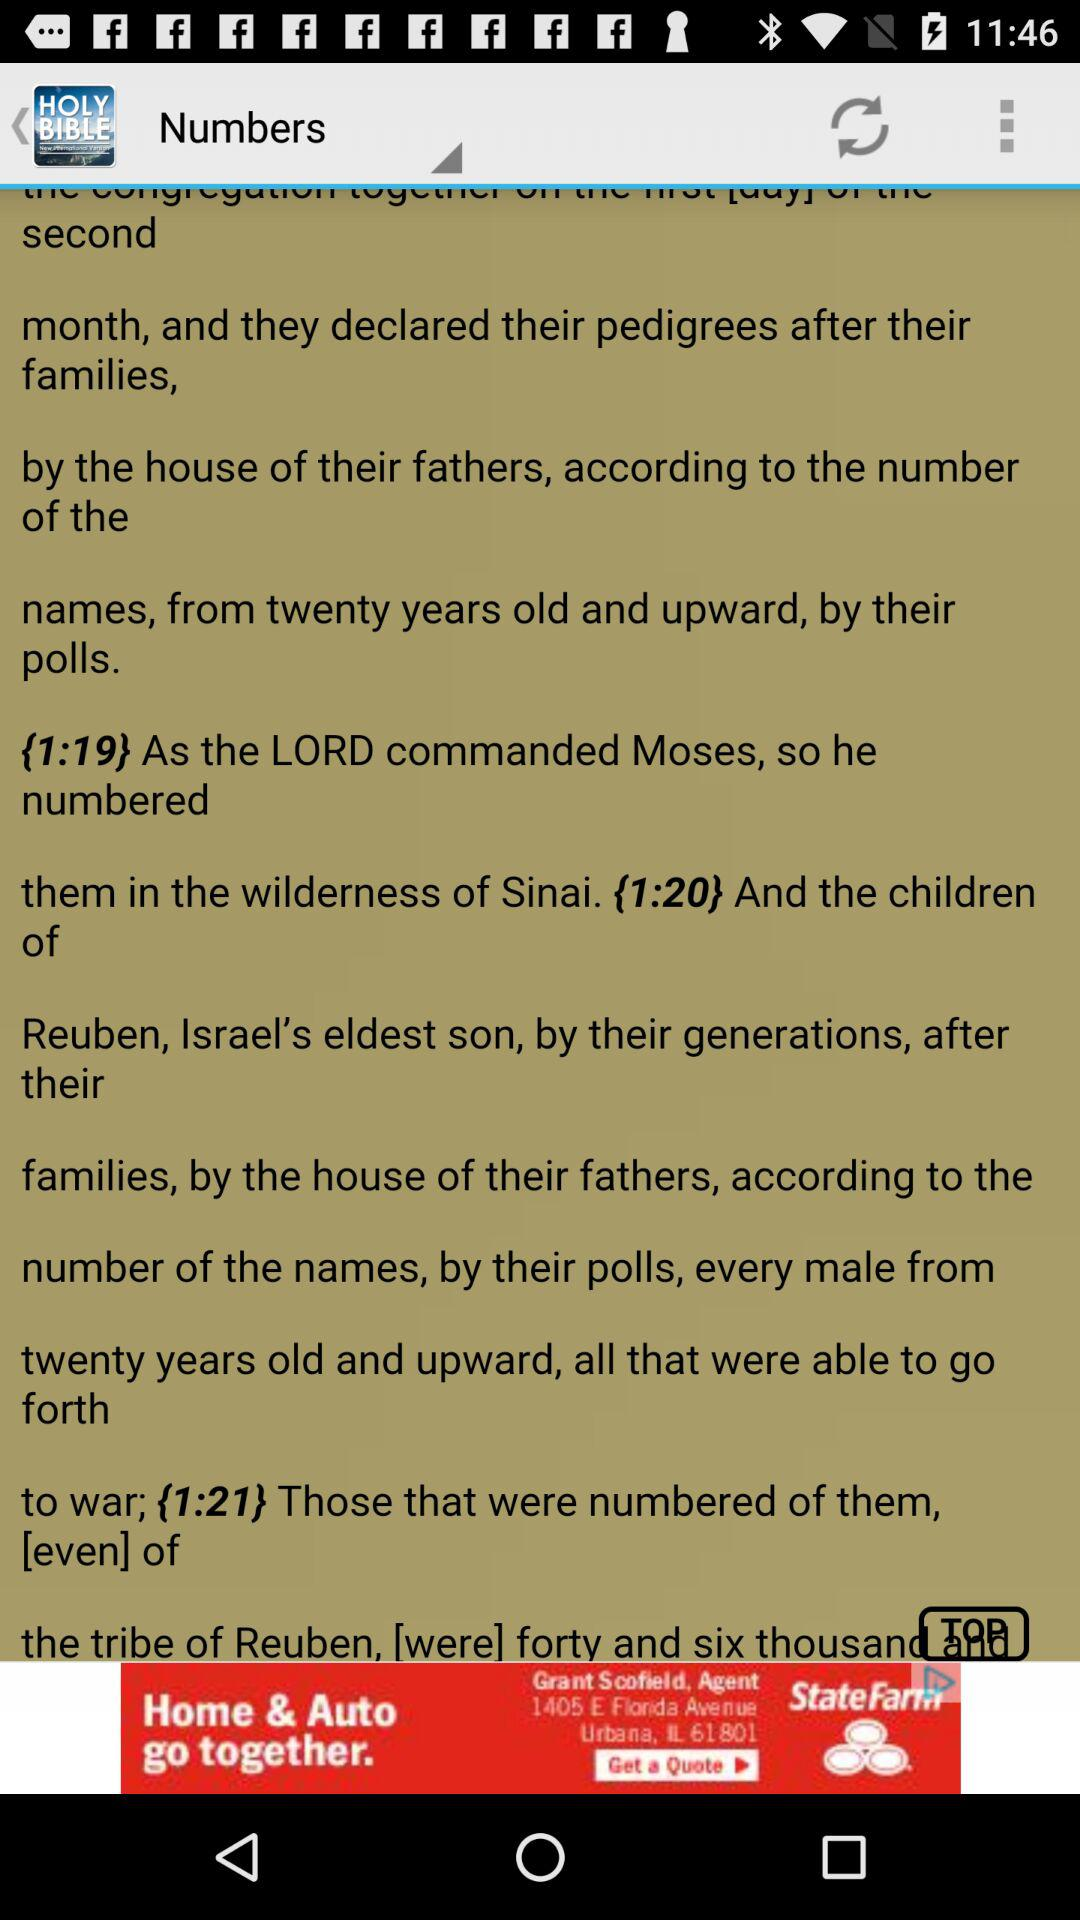What is the application name? The application name is "Niv Bible: Free Offline Bible". 